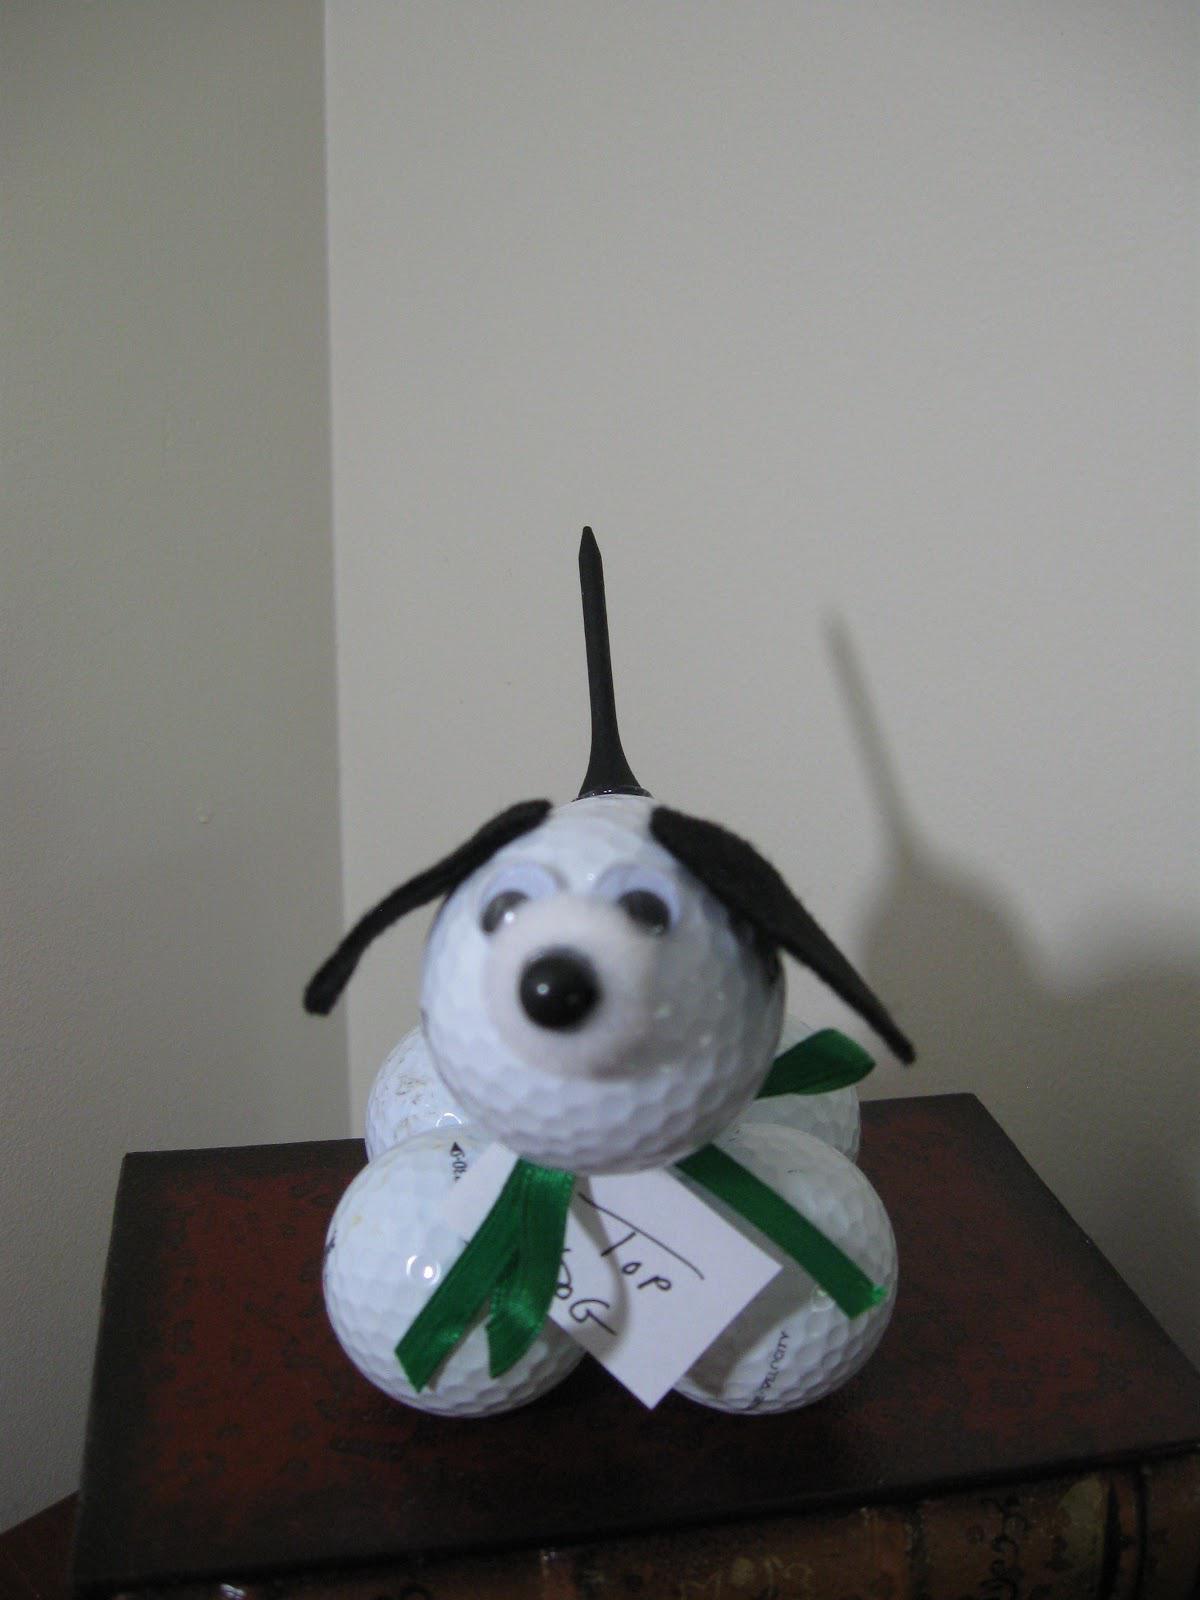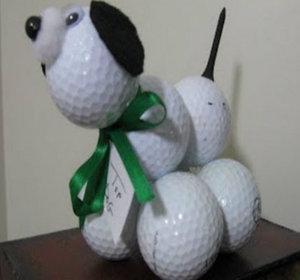The first image is the image on the left, the second image is the image on the right. Assess this claim about the two images: "All the golf balls are white.". Correct or not? Answer yes or no. Yes. The first image is the image on the left, the second image is the image on the right. Given the left and right images, does the statement "Each image includes a dog figure made out of white golf balls with a black tee tail." hold true? Answer yes or no. Yes. 